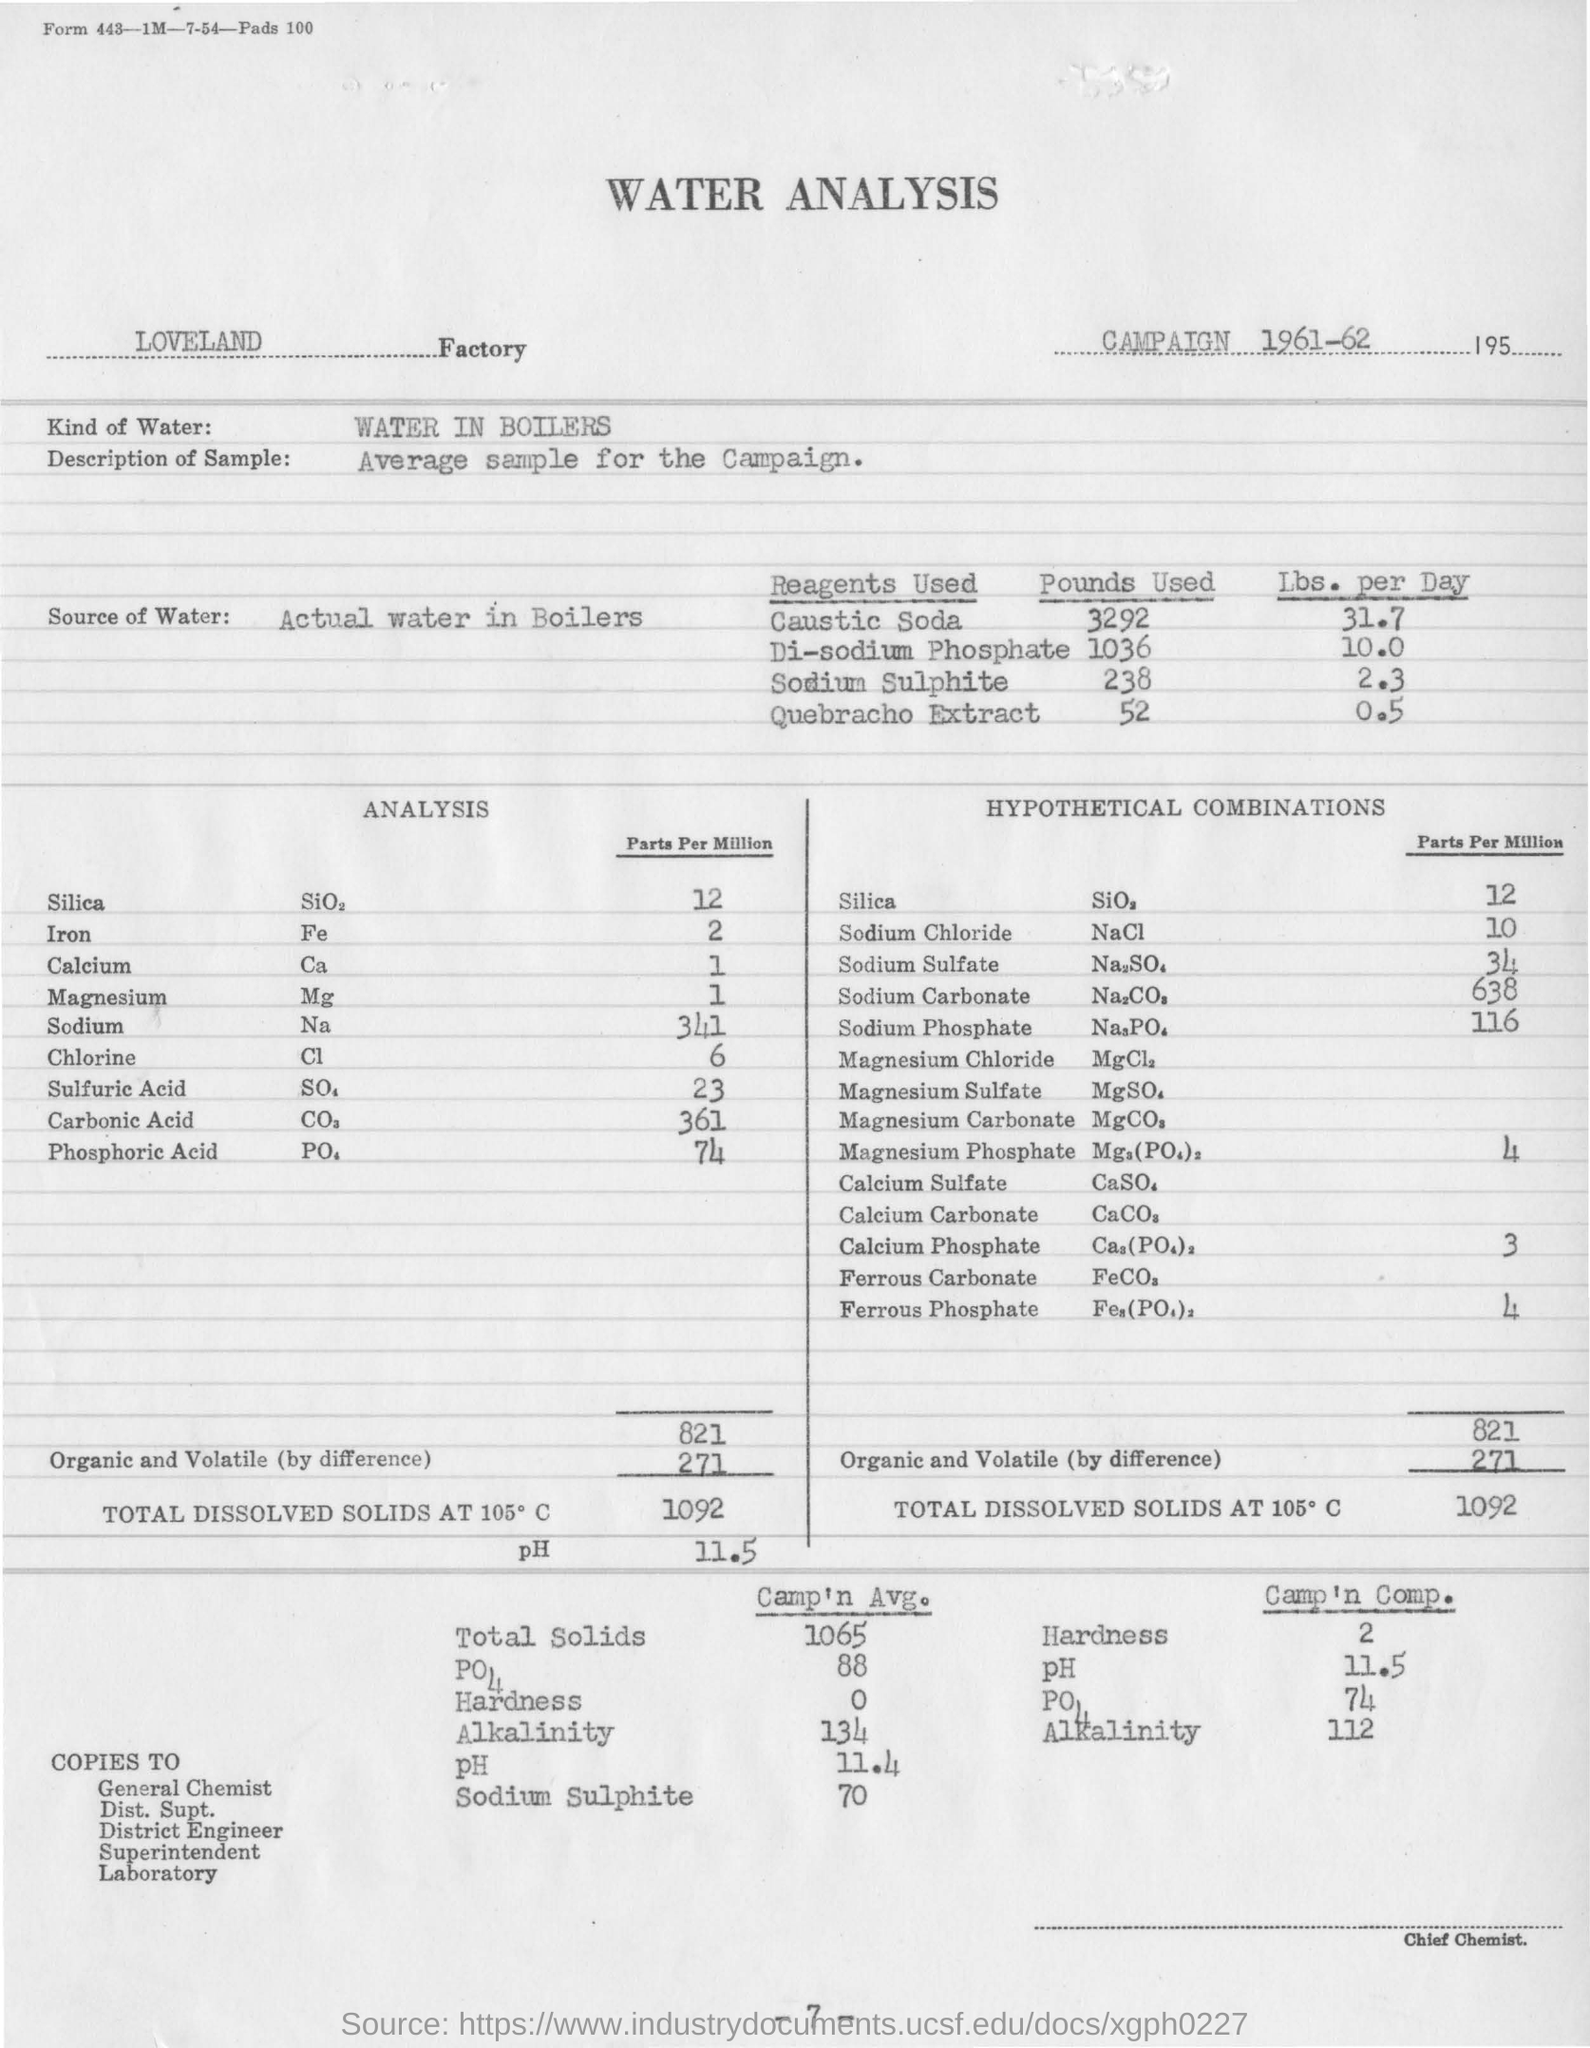During which year the campaign is held?
Provide a succinct answer. 1961-62. In which Factory is the analysis conducted?
Offer a terse response. LOVELAND Factory. What kind of water is used for the analysis?
Ensure brevity in your answer.  Water in Boilers. What is the description of the sample taken?
Provide a succinct answer. Average Sample for the campaign. What is the concentration of Silica in Parts Per Million in the analysis?
Your answer should be compact. 12. What is the concentration of chlorine in Parts Per Million in the analysis?
Offer a very short reply. 6. What is the source of water for the analysis?
Your response must be concise. Actual water in boilers. 